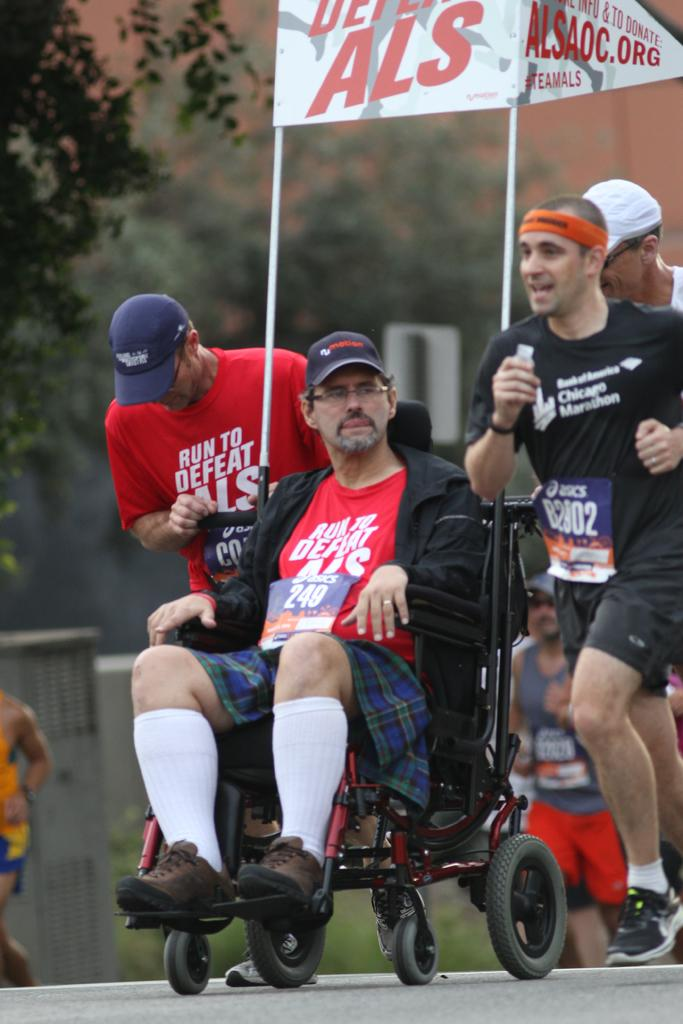What is the main subject of the image? The main subject of the image is a man sitting in a wheelchair. What are the other people in the image doing? There are three people running in the image. What type of advertisement or display is the image part of? The image appears to be a hoarding. What can be seen in the background of the image? There are trees visible, and in the background, there are people running. What type of corn is being harvested in the image? There is no corn present in the image; it features a man in a wheelchair and people running. What book is the man in the wheelchair reading in the image? There is no book visible in the image; the man is sitting in a wheelchair without any reading material. 